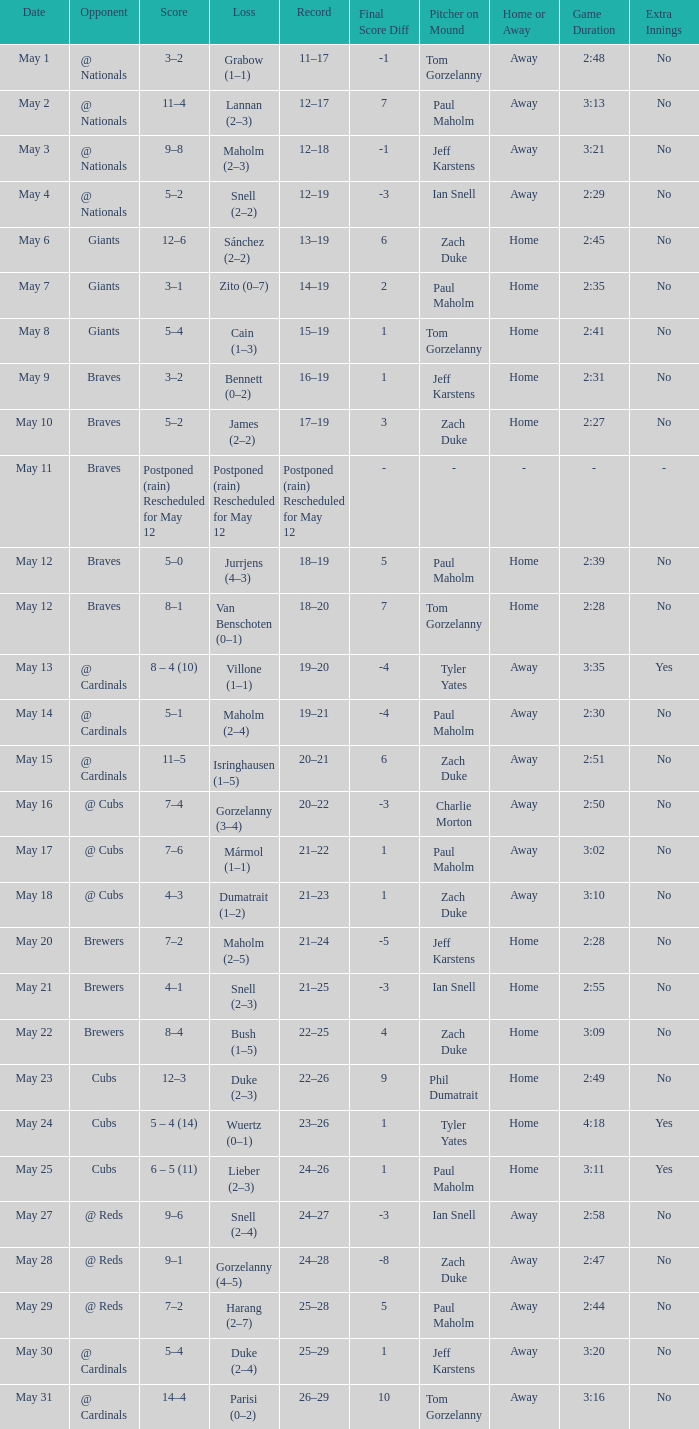What was the score of the game with a loss of Maholm (2–4)? 5–1. 